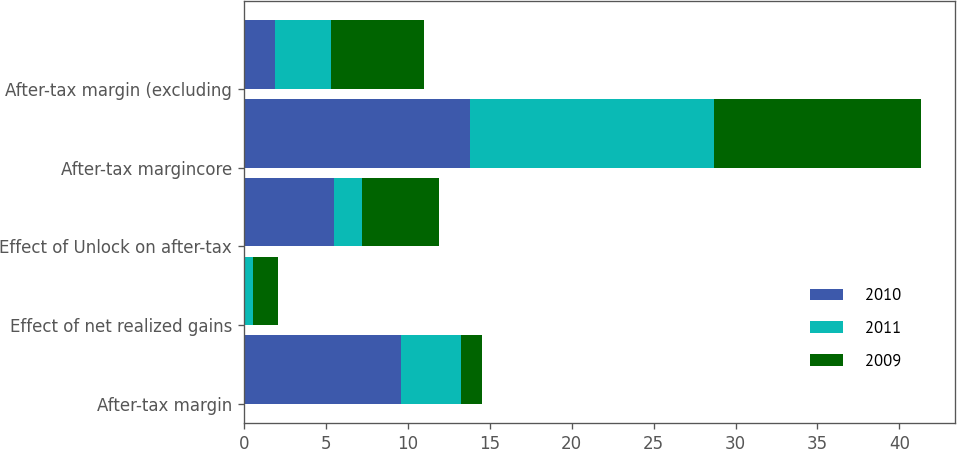Convert chart to OTSL. <chart><loc_0><loc_0><loc_500><loc_500><stacked_bar_chart><ecel><fcel>After-tax margin<fcel>Effect of net realized gains<fcel>Effect of Unlock on after-tax<fcel>After-tax margincore<fcel>After-tax margin (excluding<nl><fcel>2010<fcel>9.6<fcel>0.1<fcel>5.5<fcel>13.8<fcel>1.9<nl><fcel>2011<fcel>3.65<fcel>0.5<fcel>1.7<fcel>14.9<fcel>3.4<nl><fcel>2009<fcel>1.3<fcel>1.5<fcel>4.7<fcel>12.6<fcel>5.7<nl></chart> 